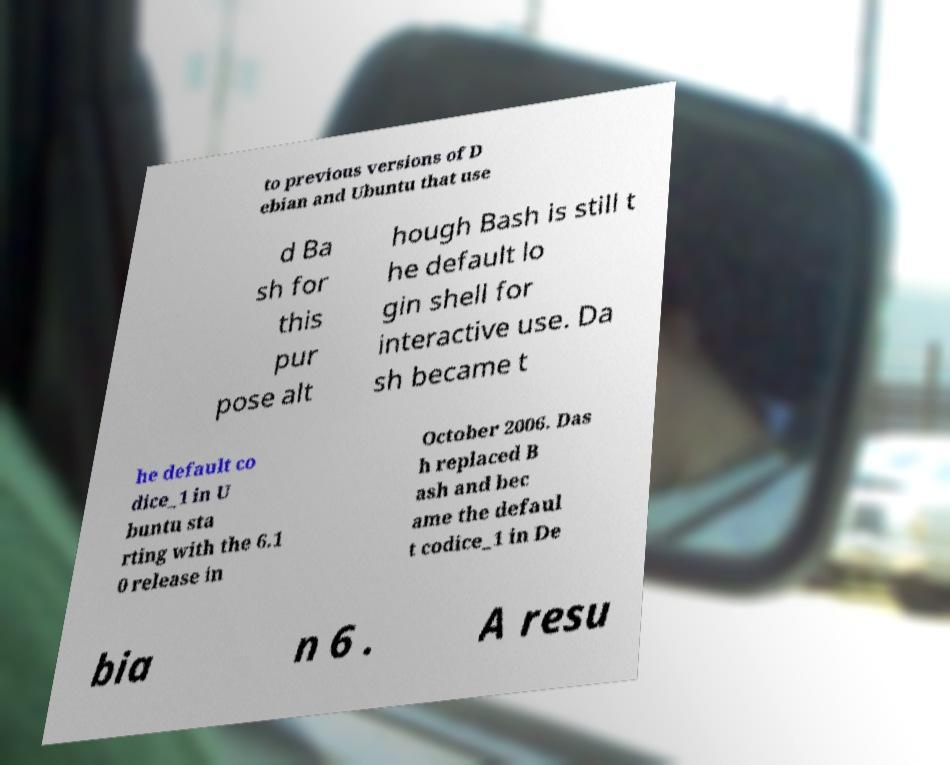For documentation purposes, I need the text within this image transcribed. Could you provide that? to previous versions of D ebian and Ubuntu that use d Ba sh for this pur pose alt hough Bash is still t he default lo gin shell for interactive use. Da sh became t he default co dice_1 in U buntu sta rting with the 6.1 0 release in October 2006. Das h replaced B ash and bec ame the defaul t codice_1 in De bia n 6 . A resu 